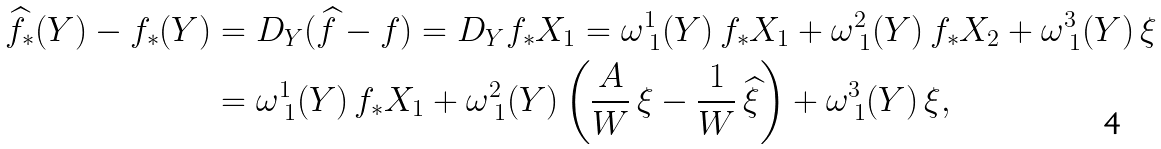Convert formula to latex. <formula><loc_0><loc_0><loc_500><loc_500>\widehat { f } _ { * } ( Y ) - f _ { * } ( Y ) & = D _ { Y } ( \widehat { f } - f ) = D _ { Y } f _ { * } X _ { 1 } = \omega ^ { 1 } _ { \ 1 } ( Y ) \, f _ { * } X _ { 1 } + \omega ^ { 2 } _ { \ 1 } ( Y ) \, f _ { * } X _ { 2 } + \omega ^ { 3 } _ { \ 1 } ( Y ) \, \xi \\ & = \omega ^ { 1 } _ { \ 1 } ( Y ) \, f _ { * } X _ { 1 } + \omega ^ { 2 } _ { \ 1 } ( Y ) \left ( \frac { A } { W } \, \xi - \frac { 1 } { W } \, \widehat { \xi } \right ) + \omega ^ { 3 } _ { \ 1 } ( Y ) \, \xi ,</formula> 